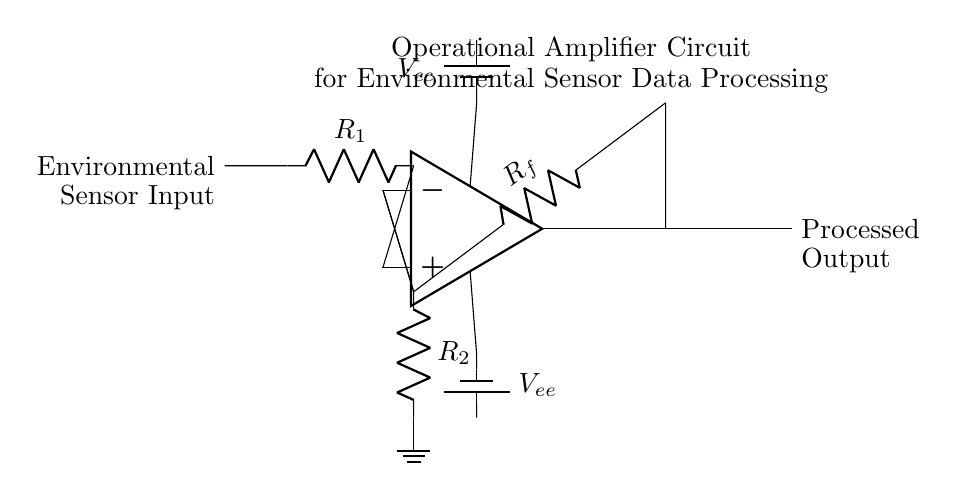What is the type of operational amplifier used in the circuit? The circuit uses a generic operational amplifier symbol, which typically represents an ideal op-amp with inverting and non-inverting inputs.
Answer: Operational amplifier What are the resistor values in the feedback loop? The feedback resistor is labeled as R_f, which indicates it is the feedback resistance value connecting the output of the op-amp to the inverting input.
Answer: R_f How many resistors are present in the circuit? There are three resistors in the circuit: R_1, R_2, and R_f. They are used for input, feedback, and grounding connections, respectively.
Answer: Three What is the purpose of the battery in the circuit? The battery provides the power supply required for the operational amplifier to function properly. It connects to both the positive and negative power rails of the op-amp.
Answer: Power supply What is the function of R_2 in this circuit? R_2 is used to provide a path to ground for the inverting input of the operational amplifier, helping to set the gain and stability of the circuit.
Answer: Grounding What does the output of the operational amplifier represent? The output represents the processed signal after amplification based on the input environmental sensor data and the feedback configuration.
Answer: Processed output What type of configuration is this op-amp circuit likely implementing? The configuration likely implements a non-inverting amplifier setup, as the input is connected to the non-inverting terminal and feedback is provided from the output to the inverting terminal.
Answer: Non-inverting 